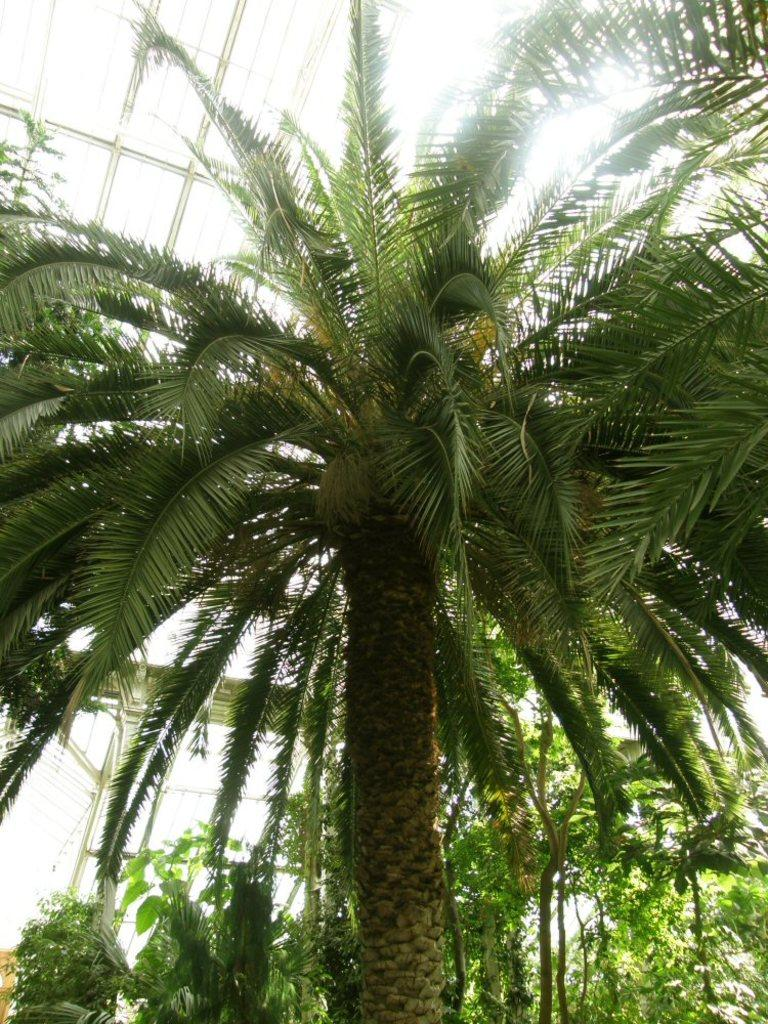What type of vegetation can be seen in the image? There are plants and trees in the image. Can you describe the architectural feature in the image? There is a glass roof in the image. How many pigs are visible in the image? There are no pigs present in the image. What type of debt is being discussed in the image? There is no mention of debt in the image. 